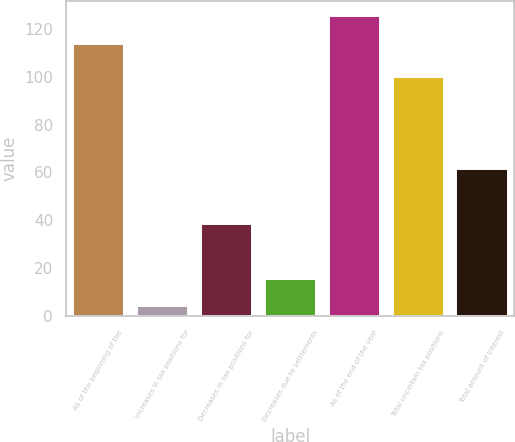Convert chart to OTSL. <chart><loc_0><loc_0><loc_500><loc_500><bar_chart><fcel>As of the beginning of the<fcel>Increases in tax positions for<fcel>Decreases in tax positions for<fcel>Decreases due to settlements<fcel>As of the end of the year<fcel>Total uncertain tax positions<fcel>Total amount of interest<nl><fcel>114<fcel>4<fcel>38.5<fcel>15.5<fcel>125.5<fcel>100<fcel>61.5<nl></chart> 